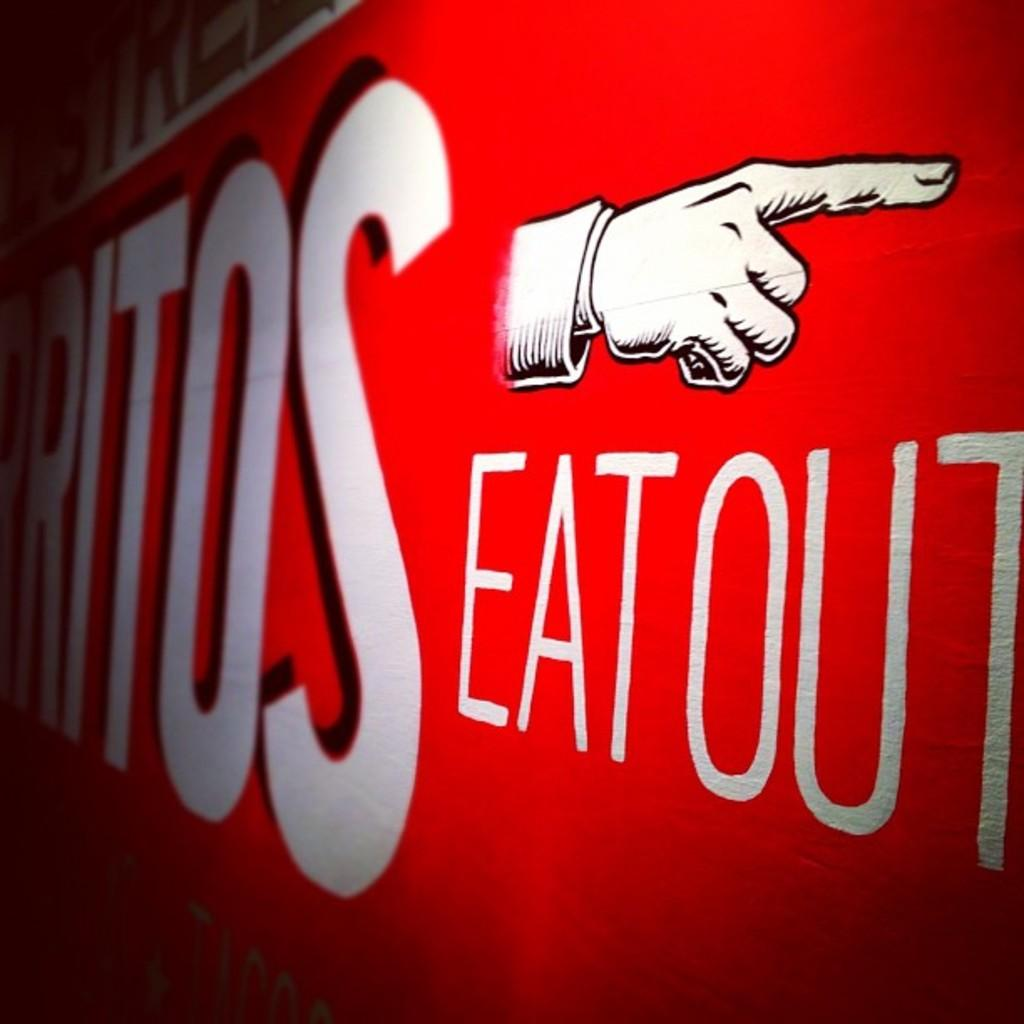What color is the wall that is visible in the image? There is a red wall in the image. What is on the red wall in the image? There is writing on the wall and a drawing of a hand in the image. What type of vacation is being planned in the image? There is no mention of a vacation in the image; it only features a red wall with writing and a drawing of a hand. 